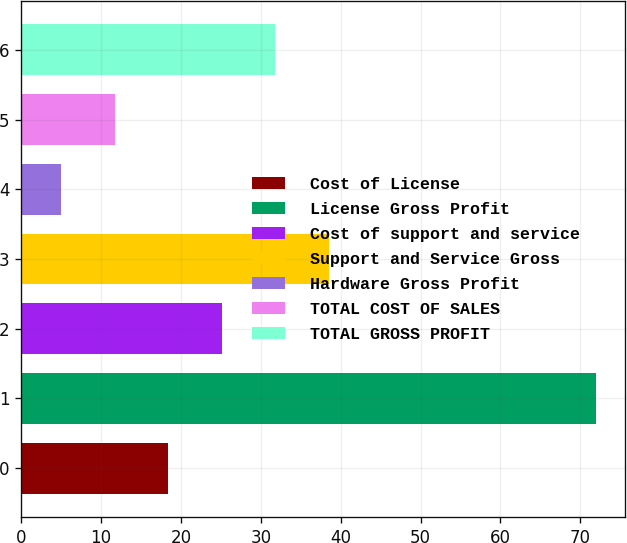<chart> <loc_0><loc_0><loc_500><loc_500><bar_chart><fcel>Cost of License<fcel>License Gross Profit<fcel>Cost of support and service<fcel>Support and Service Gross<fcel>Hardware Gross Profit<fcel>TOTAL COST OF SALES<fcel>TOTAL GROSS PROFIT<nl><fcel>18.4<fcel>72<fcel>25.1<fcel>38.5<fcel>5<fcel>11.7<fcel>31.8<nl></chart> 